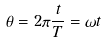Convert formula to latex. <formula><loc_0><loc_0><loc_500><loc_500>\theta = 2 \pi \frac { t } { T } = \omega t</formula> 